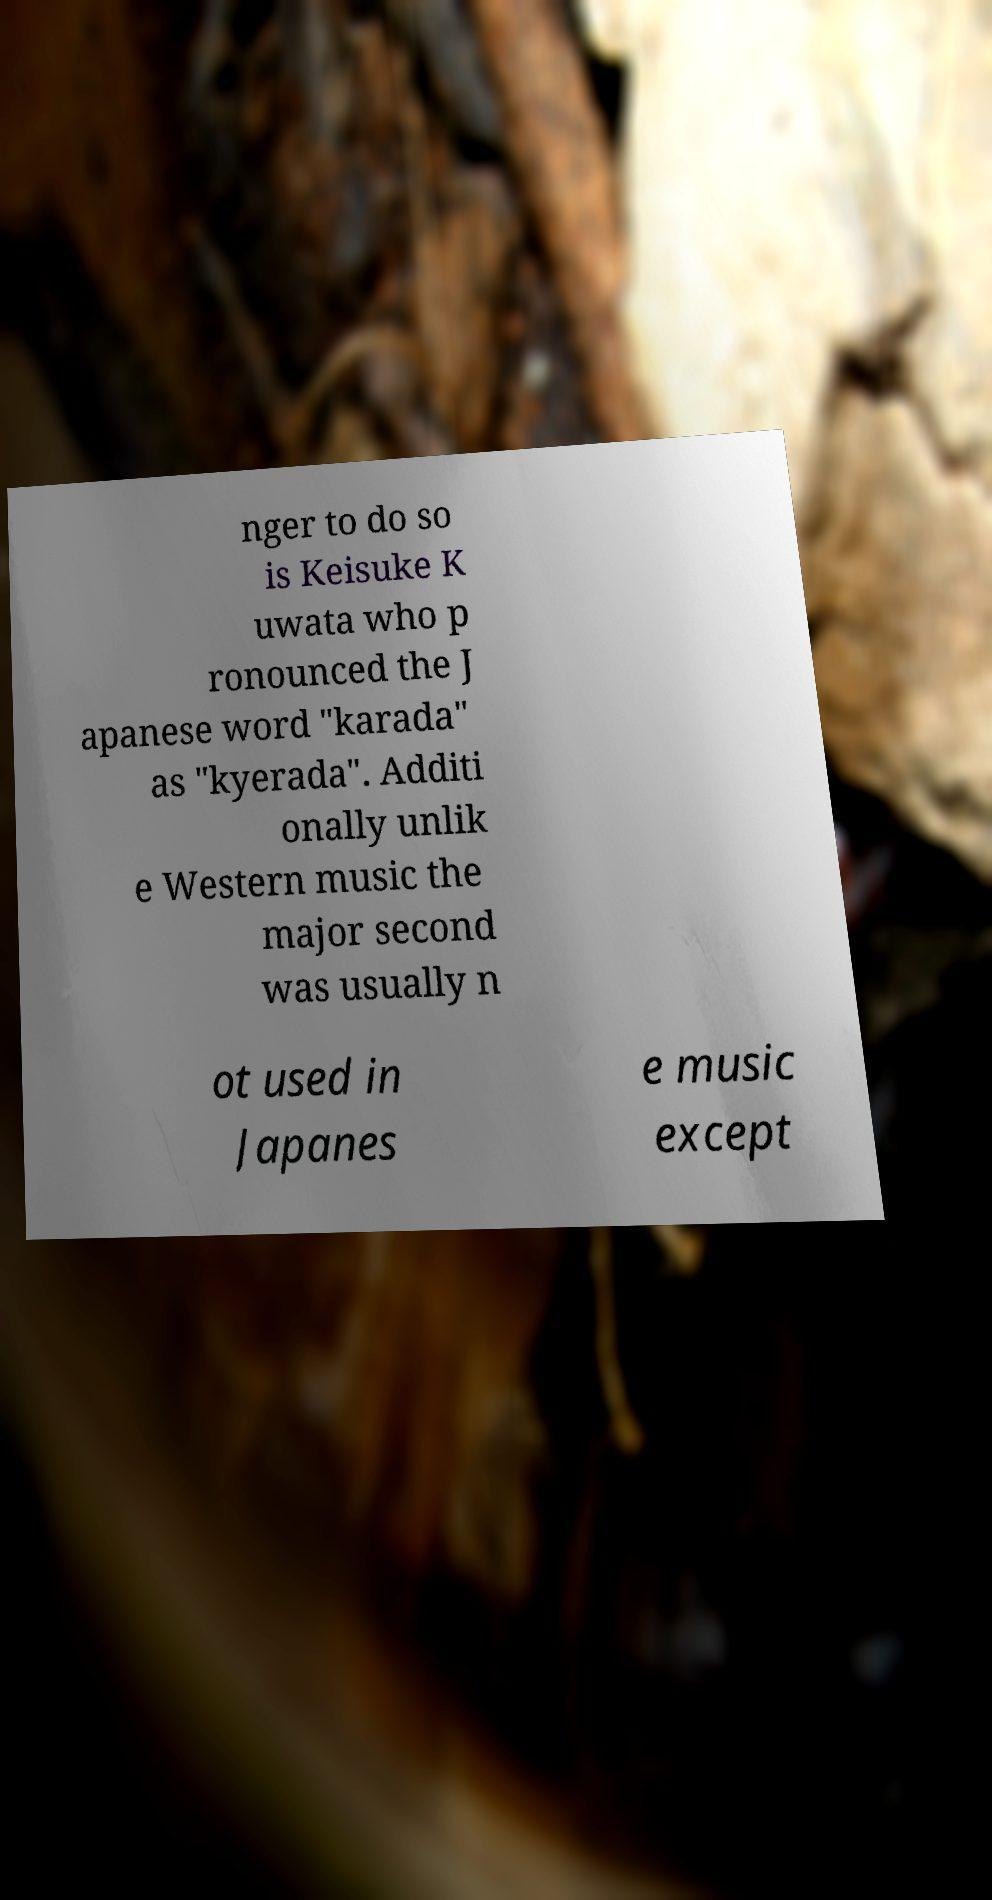Can you accurately transcribe the text from the provided image for me? nger to do so is Keisuke K uwata who p ronounced the J apanese word "karada" as "kyerada". Additi onally unlik e Western music the major second was usually n ot used in Japanes e music except 